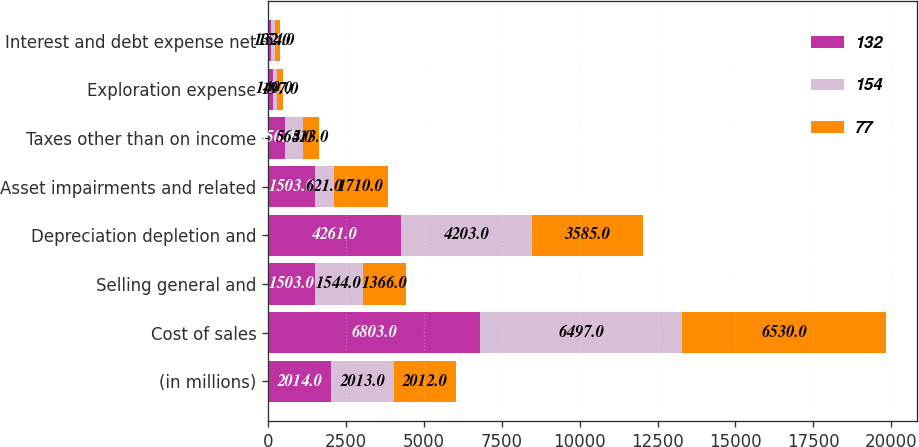Convert chart to OTSL. <chart><loc_0><loc_0><loc_500><loc_500><stacked_bar_chart><ecel><fcel>(in millions)<fcel>Cost of sales<fcel>Selling general and<fcel>Depreciation depletion and<fcel>Asset impairments and related<fcel>Taxes other than on income<fcel>Exploration expense<fcel>Interest and debt expense net<nl><fcel>132<fcel>2014<fcel>6803<fcel>1503<fcel>4261<fcel>1503<fcel>550<fcel>150<fcel>77<nl><fcel>154<fcel>2013<fcel>6497<fcel>1544<fcel>4203<fcel>621<fcel>564<fcel>140<fcel>132<nl><fcel>77<fcel>2012<fcel>6530<fcel>1366<fcel>3585<fcel>1710<fcel>513<fcel>197<fcel>154<nl></chart> 